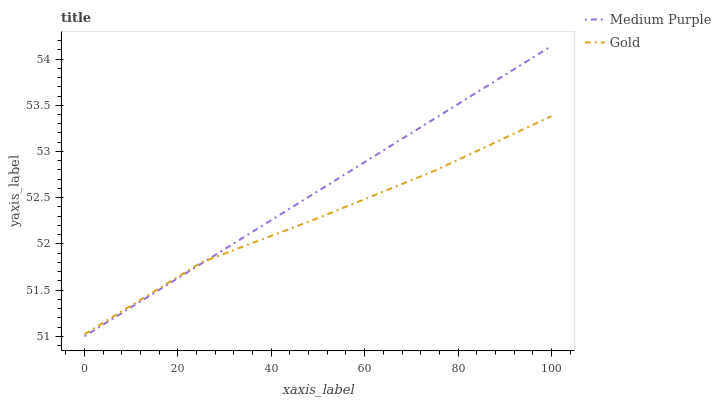Does Gold have the minimum area under the curve?
Answer yes or no. Yes. Does Medium Purple have the maximum area under the curve?
Answer yes or no. Yes. Does Gold have the maximum area under the curve?
Answer yes or no. No. Is Medium Purple the smoothest?
Answer yes or no. Yes. Is Gold the roughest?
Answer yes or no. Yes. Is Gold the smoothest?
Answer yes or no. No. Does Gold have the lowest value?
Answer yes or no. No. Does Gold have the highest value?
Answer yes or no. No. 